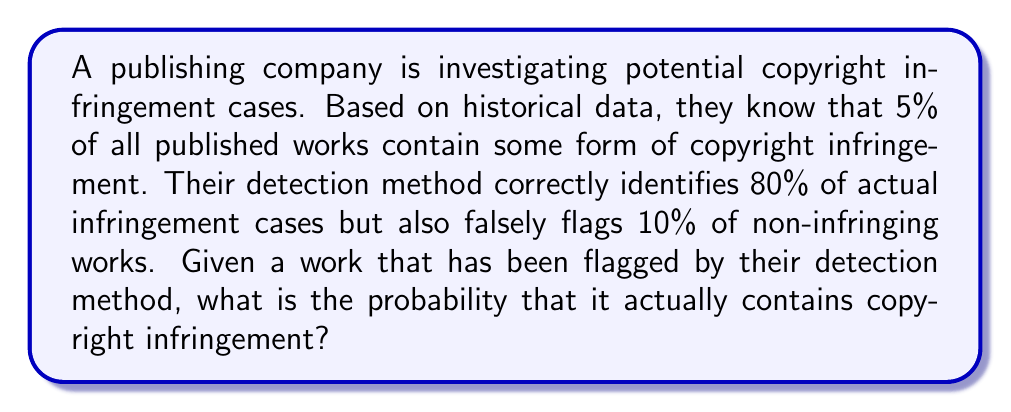Can you solve this math problem? To solve this problem, we can use Bayes' theorem. Let's define our events:

A: The work contains copyright infringement
B: The work is flagged by the detection method

We're given:
P(A) = 0.05 (5% of works contain infringement)
P(B|A) = 0.80 (80% of infringing works are correctly flagged)
P(B|not A) = 0.10 (10% of non-infringing works are falsely flagged)

We want to find P(A|B), the probability of infringement given that the work was flagged.

Bayes' theorem states:

$$ P(A|B) = \frac{P(B|A) \cdot P(A)}{P(B)} $$

To find P(B), we use the law of total probability:

$$ P(B) = P(B|A) \cdot P(A) + P(B|not A) \cdot P(not A) $$

$$ P(B) = 0.80 \cdot 0.05 + 0.10 \cdot 0.95 = 0.04 + 0.095 = 0.135 $$

Now we can apply Bayes' theorem:

$$ P(A|B) = \frac{0.80 \cdot 0.05}{0.135} = \frac{0.04}{0.135} \approx 0.2963 $$

Therefore, the probability that a flagged work actually contains copyright infringement is approximately 29.63%.
Answer: $\frac{4}{135} \approx 0.2963$ or 29.63% 